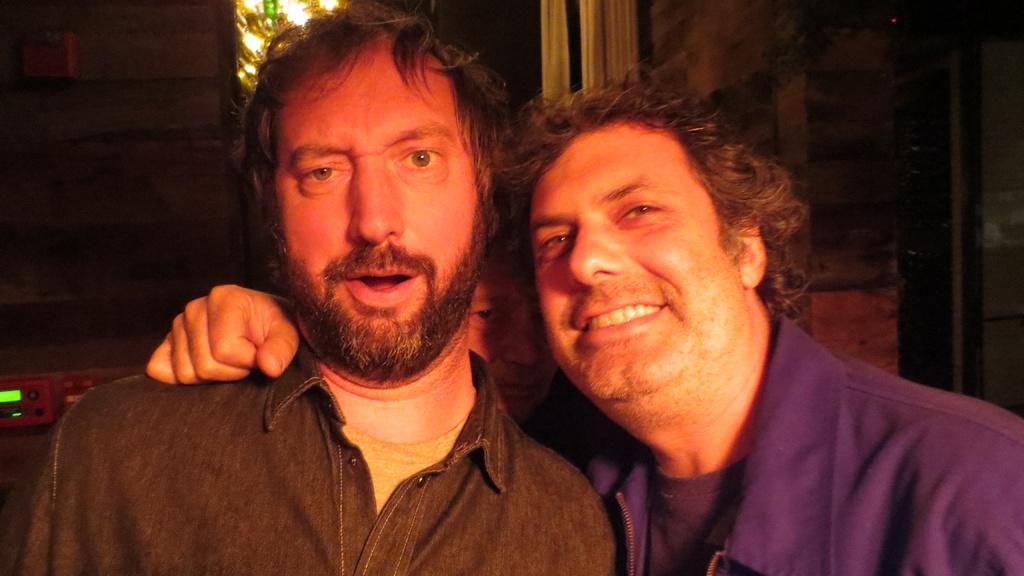How would you summarize this image in a sentence or two? This picture consists of two person , in the background light and the wall visible , in between two persons I can see another person, on the left side there is a machine. 